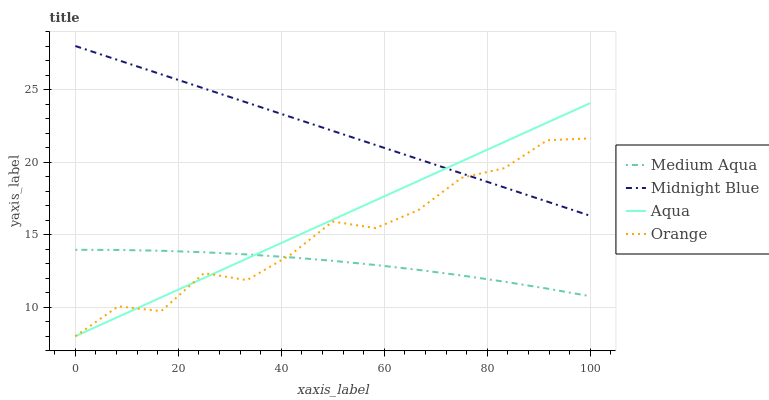Does Medium Aqua have the minimum area under the curve?
Answer yes or no. Yes. Does Midnight Blue have the maximum area under the curve?
Answer yes or no. Yes. Does Aqua have the minimum area under the curve?
Answer yes or no. No. Does Aqua have the maximum area under the curve?
Answer yes or no. No. Is Midnight Blue the smoothest?
Answer yes or no. Yes. Is Orange the roughest?
Answer yes or no. Yes. Is Aqua the smoothest?
Answer yes or no. No. Is Aqua the roughest?
Answer yes or no. No. Does Orange have the lowest value?
Answer yes or no. Yes. Does Medium Aqua have the lowest value?
Answer yes or no. No. Does Midnight Blue have the highest value?
Answer yes or no. Yes. Does Aqua have the highest value?
Answer yes or no. No. Is Medium Aqua less than Midnight Blue?
Answer yes or no. Yes. Is Midnight Blue greater than Medium Aqua?
Answer yes or no. Yes. Does Orange intersect Aqua?
Answer yes or no. Yes. Is Orange less than Aqua?
Answer yes or no. No. Is Orange greater than Aqua?
Answer yes or no. No. Does Medium Aqua intersect Midnight Blue?
Answer yes or no. No. 